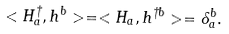<formula> <loc_0><loc_0><loc_500><loc_500>< { H } ^ { \dag } _ { a } , h ^ { b } > = < H _ { a } , { h } ^ { \dag b } > = \delta ^ { b } _ { a } .</formula> 